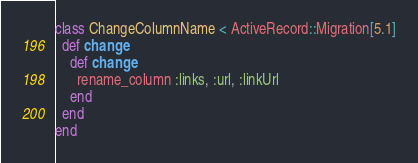Convert code to text. <code><loc_0><loc_0><loc_500><loc_500><_Ruby_>class ChangeColumnName < ActiveRecord::Migration[5.1]
  def change
    def change
      rename_column :links, :url, :linkUrl
    end
  end
end
</code> 